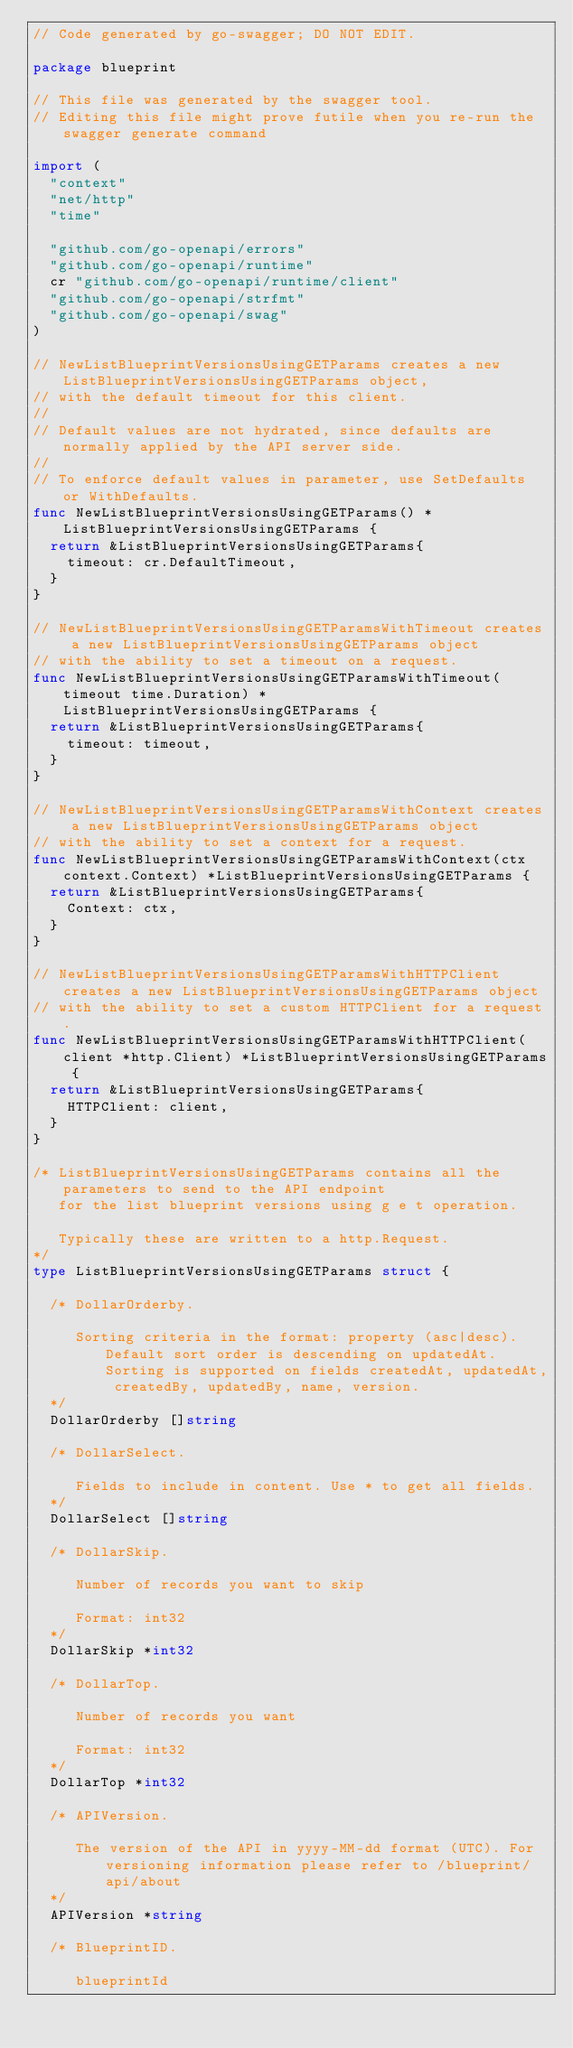<code> <loc_0><loc_0><loc_500><loc_500><_Go_>// Code generated by go-swagger; DO NOT EDIT.

package blueprint

// This file was generated by the swagger tool.
// Editing this file might prove futile when you re-run the swagger generate command

import (
	"context"
	"net/http"
	"time"

	"github.com/go-openapi/errors"
	"github.com/go-openapi/runtime"
	cr "github.com/go-openapi/runtime/client"
	"github.com/go-openapi/strfmt"
	"github.com/go-openapi/swag"
)

// NewListBlueprintVersionsUsingGETParams creates a new ListBlueprintVersionsUsingGETParams object,
// with the default timeout for this client.
//
// Default values are not hydrated, since defaults are normally applied by the API server side.
//
// To enforce default values in parameter, use SetDefaults or WithDefaults.
func NewListBlueprintVersionsUsingGETParams() *ListBlueprintVersionsUsingGETParams {
	return &ListBlueprintVersionsUsingGETParams{
		timeout: cr.DefaultTimeout,
	}
}

// NewListBlueprintVersionsUsingGETParamsWithTimeout creates a new ListBlueprintVersionsUsingGETParams object
// with the ability to set a timeout on a request.
func NewListBlueprintVersionsUsingGETParamsWithTimeout(timeout time.Duration) *ListBlueprintVersionsUsingGETParams {
	return &ListBlueprintVersionsUsingGETParams{
		timeout: timeout,
	}
}

// NewListBlueprintVersionsUsingGETParamsWithContext creates a new ListBlueprintVersionsUsingGETParams object
// with the ability to set a context for a request.
func NewListBlueprintVersionsUsingGETParamsWithContext(ctx context.Context) *ListBlueprintVersionsUsingGETParams {
	return &ListBlueprintVersionsUsingGETParams{
		Context: ctx,
	}
}

// NewListBlueprintVersionsUsingGETParamsWithHTTPClient creates a new ListBlueprintVersionsUsingGETParams object
// with the ability to set a custom HTTPClient for a request.
func NewListBlueprintVersionsUsingGETParamsWithHTTPClient(client *http.Client) *ListBlueprintVersionsUsingGETParams {
	return &ListBlueprintVersionsUsingGETParams{
		HTTPClient: client,
	}
}

/* ListBlueprintVersionsUsingGETParams contains all the parameters to send to the API endpoint
   for the list blueprint versions using g e t operation.

   Typically these are written to a http.Request.
*/
type ListBlueprintVersionsUsingGETParams struct {

	/* DollarOrderby.

	   Sorting criteria in the format: property (asc|desc). Default sort order is descending on updatedAt. Sorting is supported on fields createdAt, updatedAt, createdBy, updatedBy, name, version.
	*/
	DollarOrderby []string

	/* DollarSelect.

	   Fields to include in content. Use * to get all fields.
	*/
	DollarSelect []string

	/* DollarSkip.

	   Number of records you want to skip

	   Format: int32
	*/
	DollarSkip *int32

	/* DollarTop.

	   Number of records you want

	   Format: int32
	*/
	DollarTop *int32

	/* APIVersion.

	   The version of the API in yyyy-MM-dd format (UTC). For versioning information please refer to /blueprint/api/about
	*/
	APIVersion *string

	/* BlueprintID.

	   blueprintId
</code> 